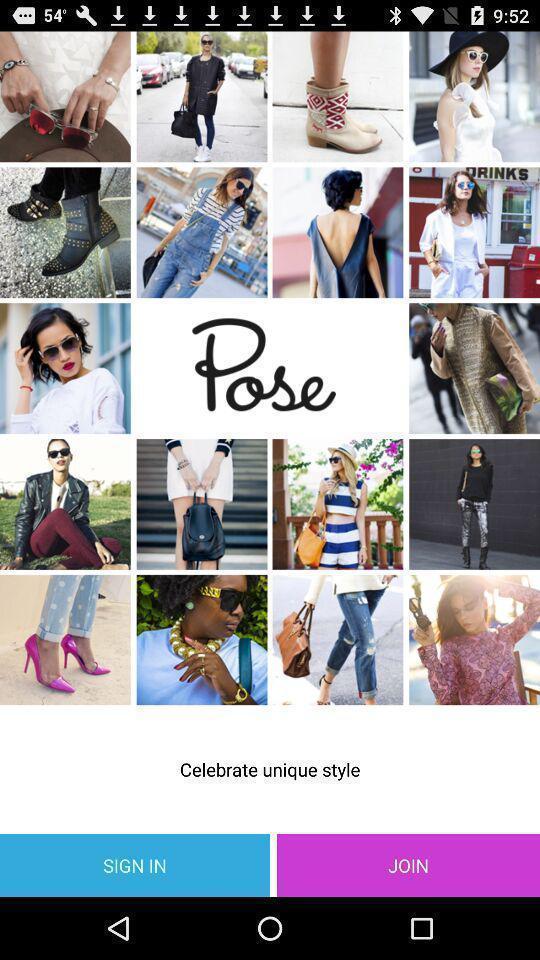Provide a detailed account of this screenshot. Sign page. 